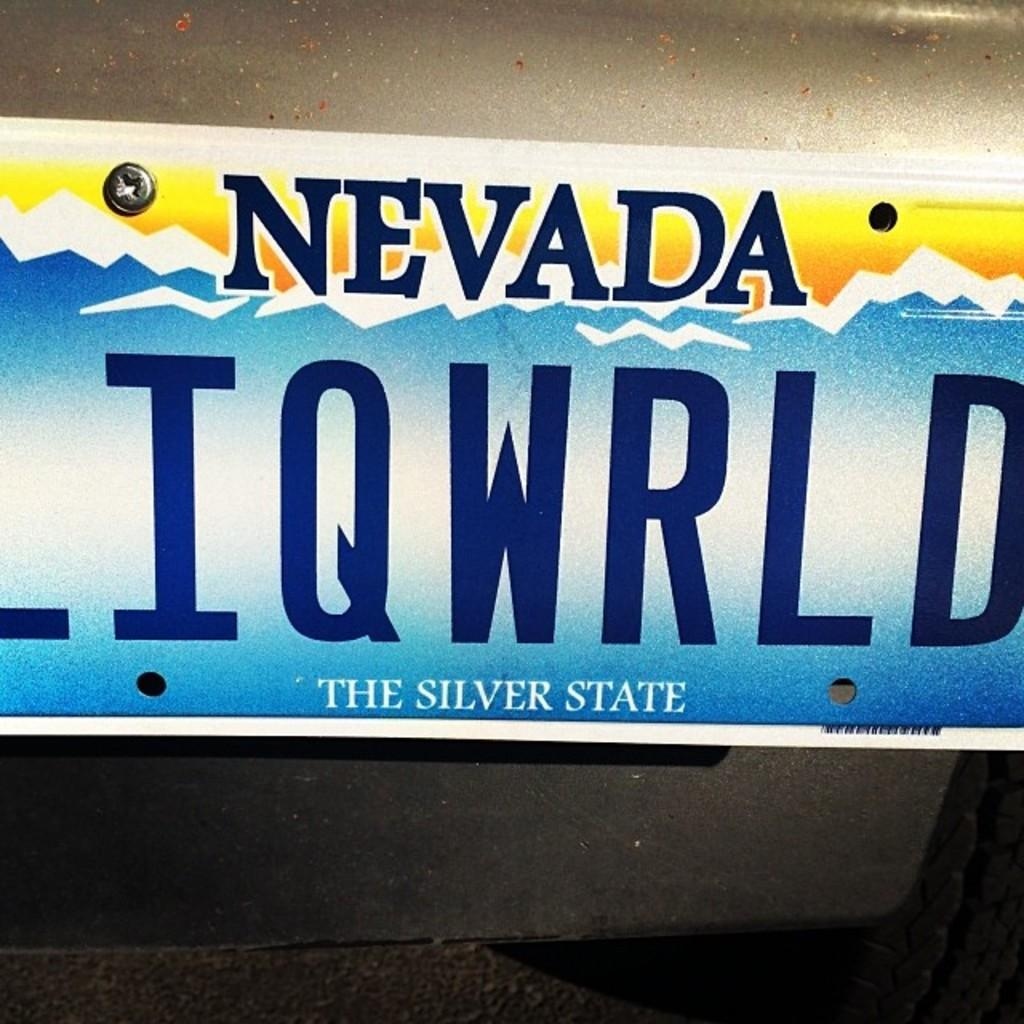<image>
Describe the image concisely. a nevada license plate that says LIQWRLD, the silver state 